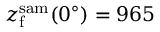Convert formula to latex. <formula><loc_0><loc_0><loc_500><loc_500>z _ { f } ^ { s a m } ( 0 ^ { \circ } ) = 9 6 5</formula> 